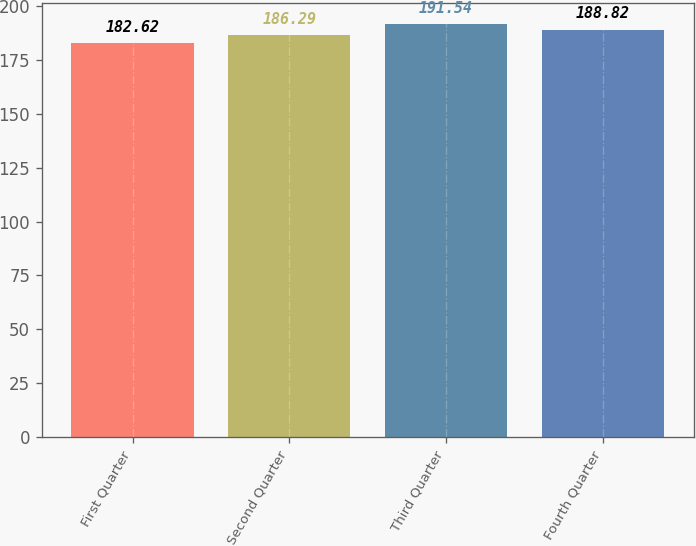Convert chart to OTSL. <chart><loc_0><loc_0><loc_500><loc_500><bar_chart><fcel>First Quarter<fcel>Second Quarter<fcel>Third Quarter<fcel>Fourth Quarter<nl><fcel>182.62<fcel>186.29<fcel>191.54<fcel>188.82<nl></chart> 